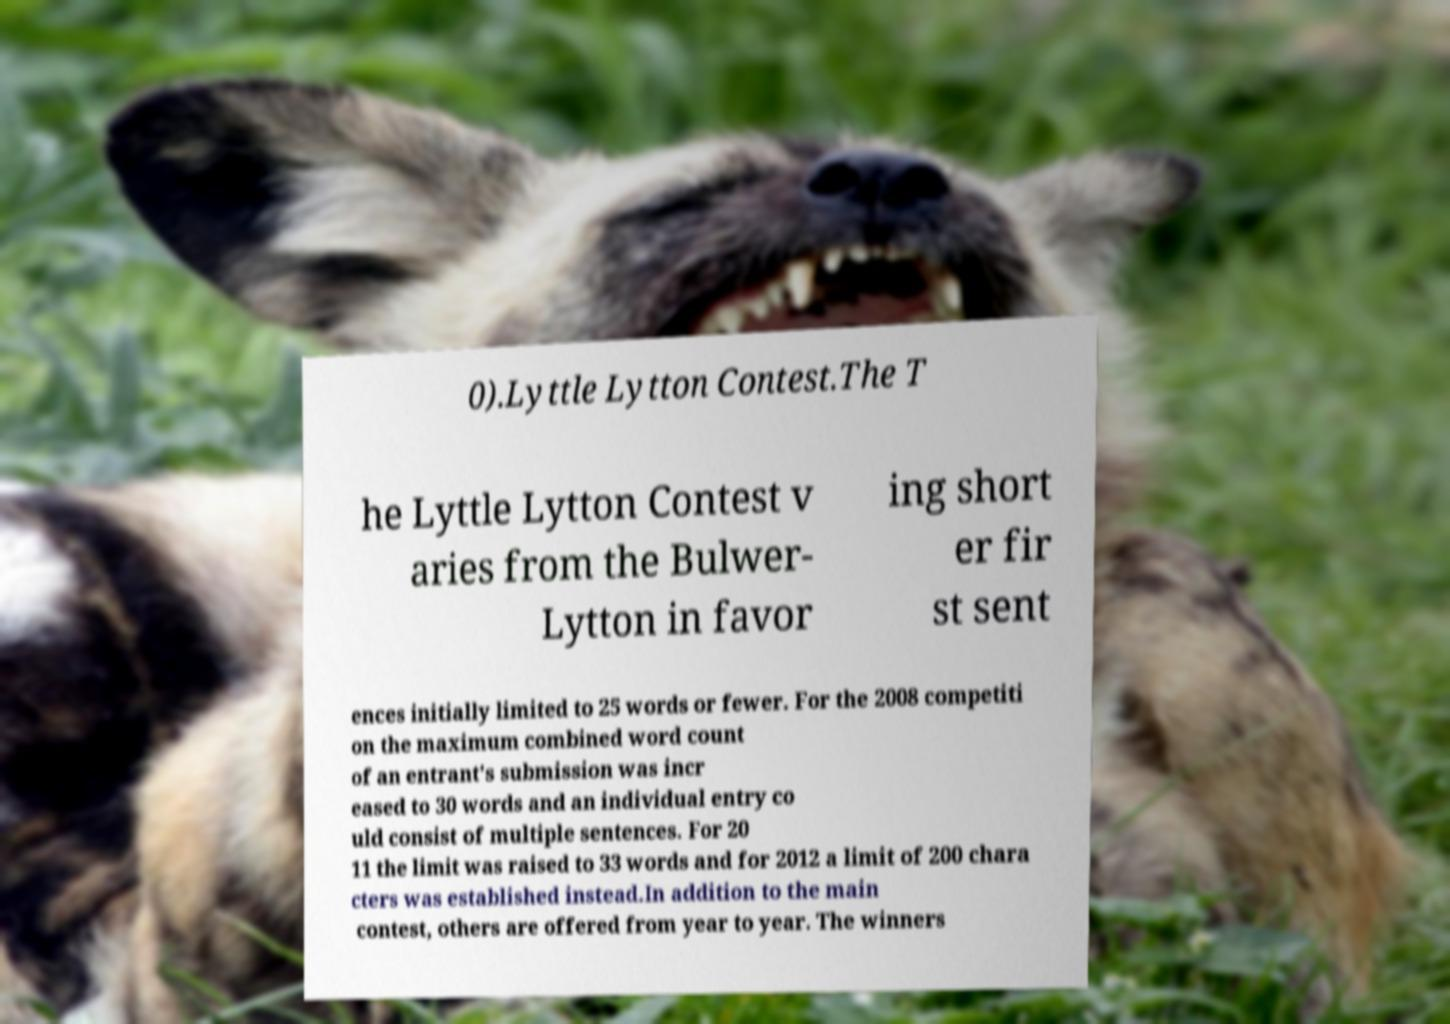There's text embedded in this image that I need extracted. Can you transcribe it verbatim? 0).Lyttle Lytton Contest.The T he Lyttle Lytton Contest v aries from the Bulwer- Lytton in favor ing short er fir st sent ences initially limited to 25 words or fewer. For the 2008 competiti on the maximum combined word count of an entrant's submission was incr eased to 30 words and an individual entry co uld consist of multiple sentences. For 20 11 the limit was raised to 33 words and for 2012 a limit of 200 chara cters was established instead.In addition to the main contest, others are offered from year to year. The winners 